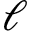<formula> <loc_0><loc_0><loc_500><loc_500>\ell</formula> 